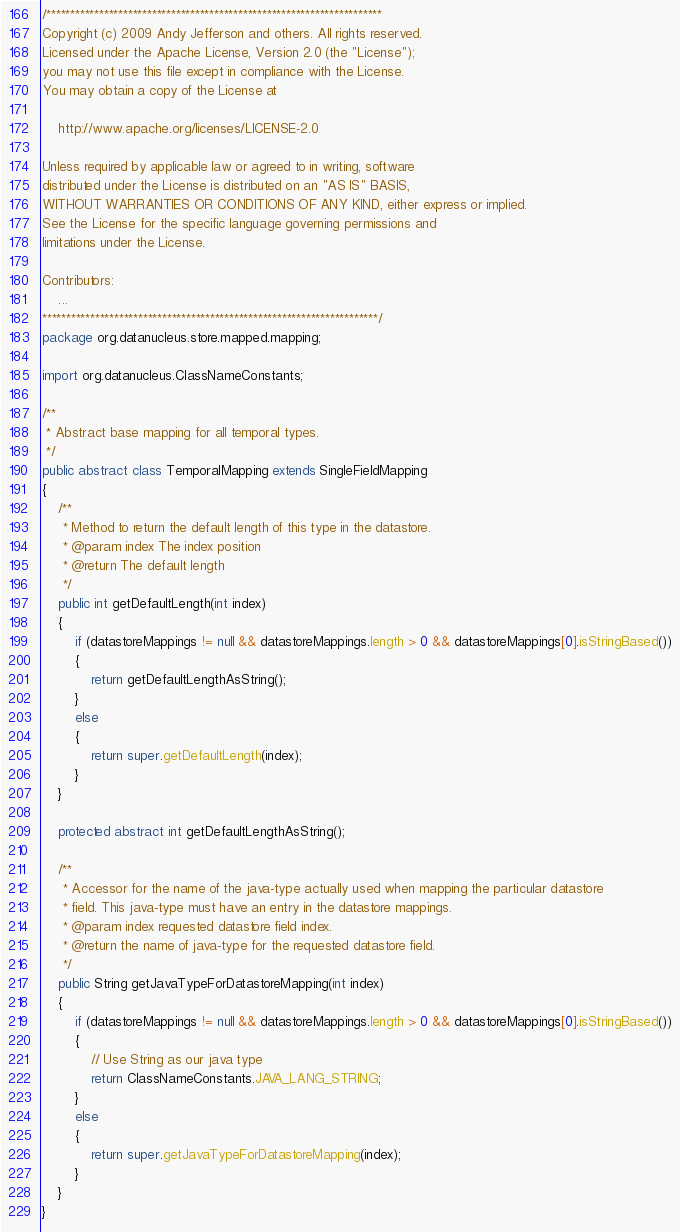Convert code to text. <code><loc_0><loc_0><loc_500><loc_500><_Java_>/**********************************************************************
Copyright (c) 2009 Andy Jefferson and others. All rights reserved. 
Licensed under the Apache License, Version 2.0 (the "License");
you may not use this file except in compliance with the License.
You may obtain a copy of the License at

    http://www.apache.org/licenses/LICENSE-2.0

Unless required by applicable law or agreed to in writing, software
distributed under the License is distributed on an "AS IS" BASIS,
WITHOUT WARRANTIES OR CONDITIONS OF ANY KIND, either express or implied.
See the License for the specific language governing permissions and
limitations under the License.

Contributors:
    ...
**********************************************************************/
package org.datanucleus.store.mapped.mapping;

import org.datanucleus.ClassNameConstants;

/**
 * Abstract base mapping for all temporal types.
 */
public abstract class TemporalMapping extends SingleFieldMapping
{
    /**
     * Method to return the default length of this type in the datastore.
     * @param index The index position
     * @return The default length
     */
    public int getDefaultLength(int index)
    {
        if (datastoreMappings != null && datastoreMappings.length > 0 && datastoreMappings[0].isStringBased())
        {
            return getDefaultLengthAsString();
        }
        else
        {
            return super.getDefaultLength(index);
        }
    }

    protected abstract int getDefaultLengthAsString();

    /**
     * Accessor for the name of the java-type actually used when mapping the particular datastore
     * field. This java-type must have an entry in the datastore mappings.
     * @param index requested datastore field index.
     * @return the name of java-type for the requested datastore field.
     */
    public String getJavaTypeForDatastoreMapping(int index)
    {
        if (datastoreMappings != null && datastoreMappings.length > 0 && datastoreMappings[0].isStringBased())
        {
            // Use String as our java type
            return ClassNameConstants.JAVA_LANG_STRING;
        }
        else
        {
            return super.getJavaTypeForDatastoreMapping(index);
        }
    }
}</code> 